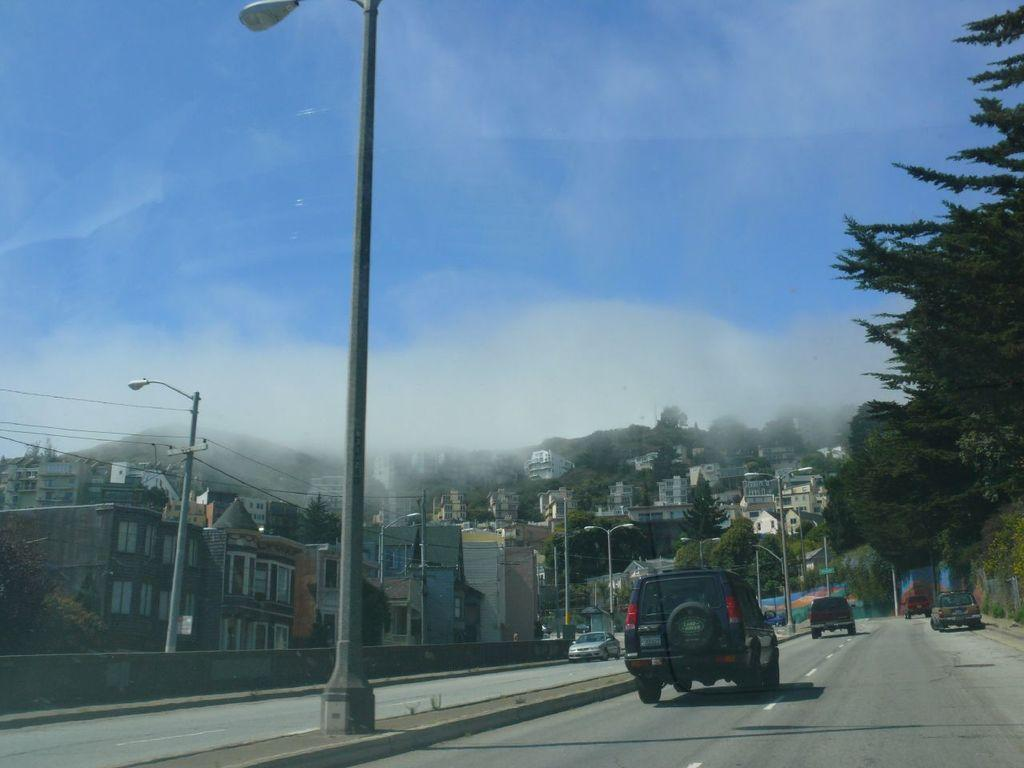What can be seen parked on the road in the image? There are vehicles parked on the road in the image. What structures are present in the image besides the vehicles? There is a group of light poles in the image. What can be seen in the background of the image? There are trees and buildings visible in the background of the image. How would you describe the sky in the image? The sky is cloudy in the background of the image. What type of meat is being grilled on the light pole in the image? There is no meat or grilling activity present in the image; the light poles are not associated with any food preparation. 